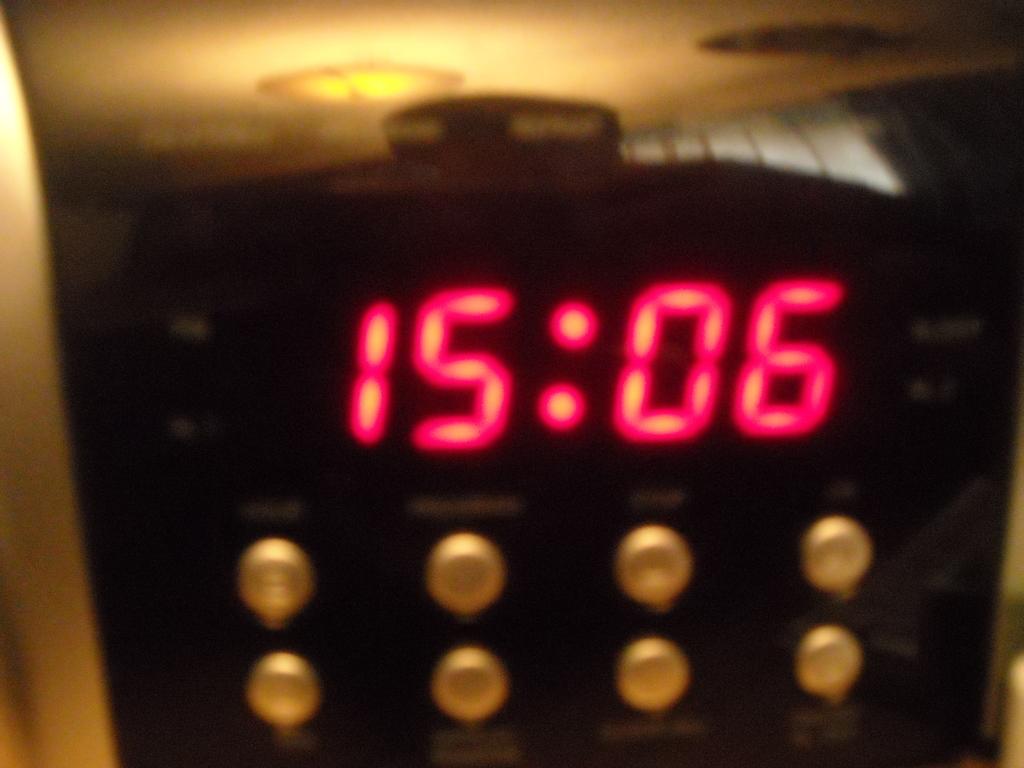What time is it?
Your answer should be compact. 15:06. 